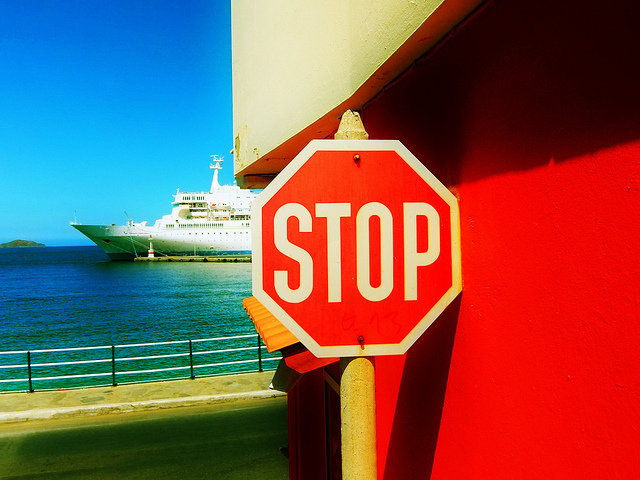What time of day does it seem to be in the image? Given the brightness of the scene and the length of the shadows present, it seems to be midday. The sun appears high, suggesting that it is neither early morning nor late afternoon. 